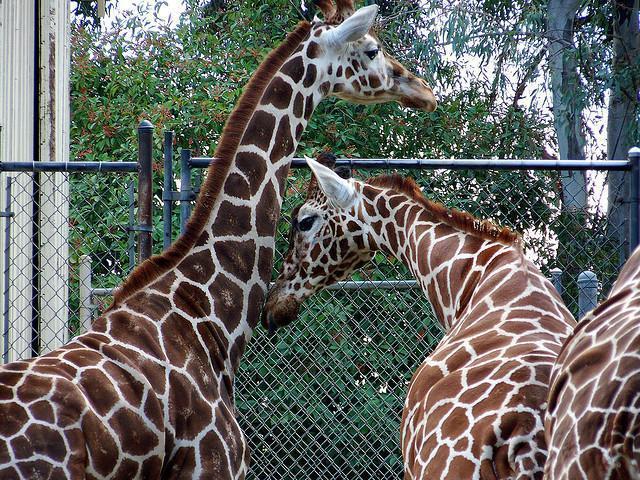How many giraffes can you see?
Give a very brief answer. 3. How many cars are in the intersection?
Give a very brief answer. 0. 